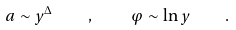<formula> <loc_0><loc_0><loc_500><loc_500>a \sim y ^ { \Delta } \quad , \quad \varphi \sim \ln y \quad .</formula> 